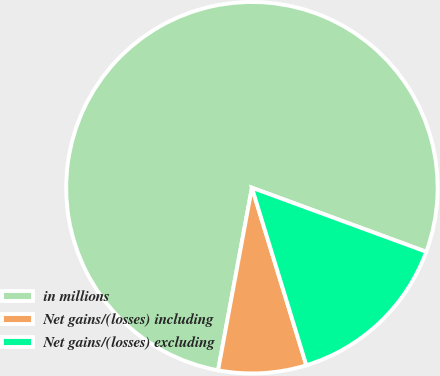Convert chart. <chart><loc_0><loc_0><loc_500><loc_500><pie_chart><fcel>in millions<fcel>Net gains/(losses) including<fcel>Net gains/(losses) excluding<nl><fcel>77.69%<fcel>7.65%<fcel>14.66%<nl></chart> 